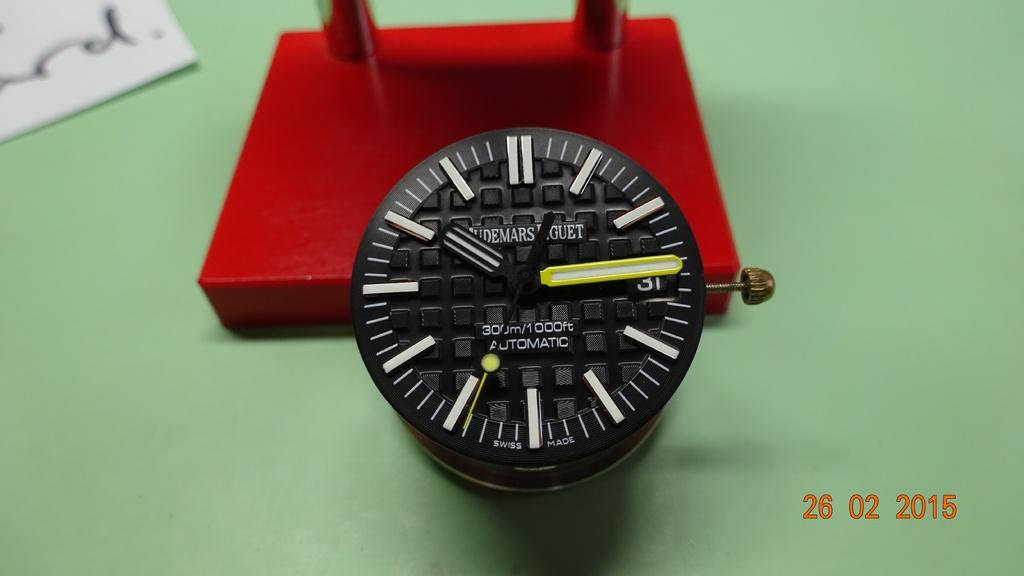Provide a one-sentence caption for the provided image. a black and white watch that is Automatic and reads 300m/1000ft. 